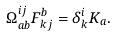<formula> <loc_0><loc_0><loc_500><loc_500>\Omega ^ { i j } _ { a b } F ^ { b } _ { k j } = \delta ^ { i } _ { k } K _ { a } .</formula> 